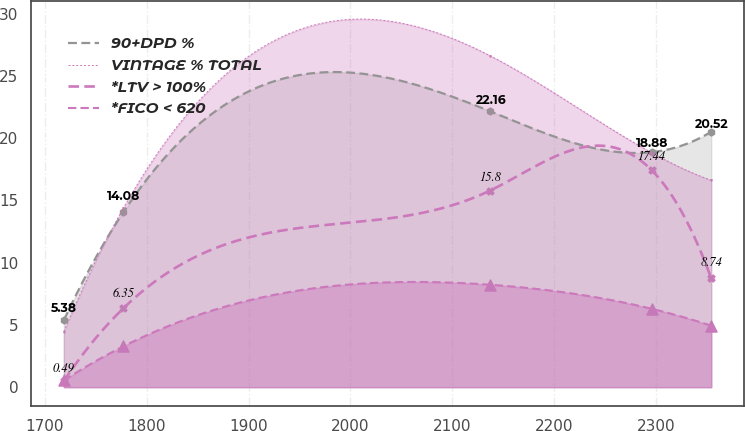Convert chart. <chart><loc_0><loc_0><loc_500><loc_500><line_chart><ecel><fcel>90+DPD %<fcel>VINTAGE % TOTAL<fcel>*LTV > 100%<fcel>*FICO < 620<nl><fcel>1718.51<fcel>5.38<fcel>4.47<fcel>0.49<fcel>0.54<nl><fcel>1777.1<fcel>14.08<fcel>14.4<fcel>6.35<fcel>3.29<nl><fcel>2137.25<fcel>22.16<fcel>26.62<fcel>15.8<fcel>8.23<nl><fcel>2295.72<fcel>18.88<fcel>18.84<fcel>17.44<fcel>6.3<nl><fcel>2354.31<fcel>20.52<fcel>16.62<fcel>8.74<fcel>4.94<nl></chart> 